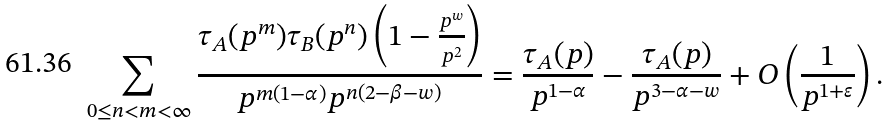<formula> <loc_0><loc_0><loc_500><loc_500>\sum _ { 0 \leq n < m < \infty } \frac { \tau _ { A } ( p ^ { m } ) \tau _ { B } ( p ^ { n } ) \left ( 1 - \frac { p ^ { w } } { p ^ { 2 } } \right ) } { p ^ { m ( 1 - \alpha ) } p ^ { n ( 2 - \beta - w ) } } = \frac { \tau _ { A } ( p ) } { p ^ { 1 - \alpha } } - \frac { \tau _ { A } ( p ) } { p ^ { 3 - \alpha - w } } + O \left ( \frac { 1 } { p ^ { 1 + \varepsilon } } \right ) .</formula> 